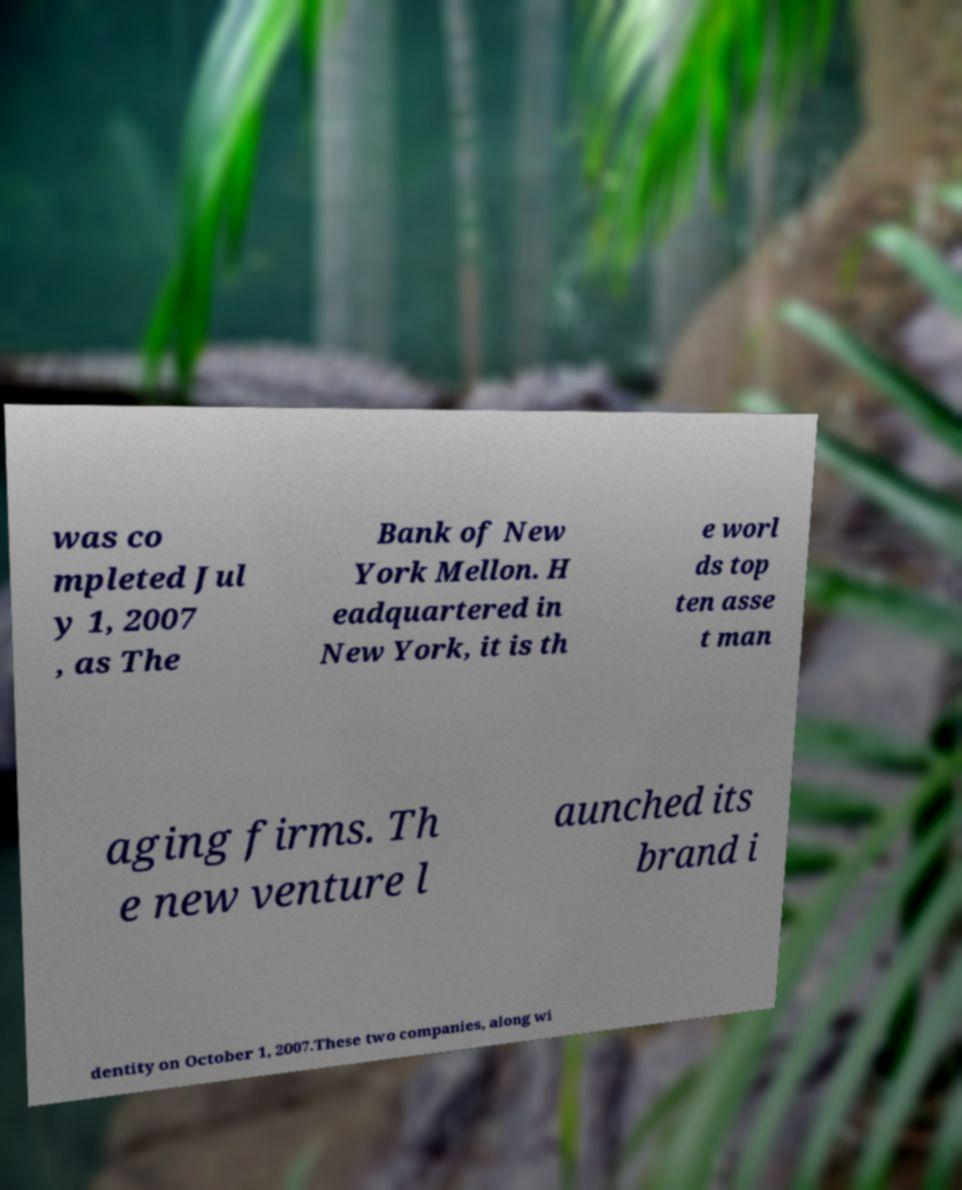Please identify and transcribe the text found in this image. was co mpleted Jul y 1, 2007 , as The Bank of New York Mellon. H eadquartered in New York, it is th e worl ds top ten asse t man aging firms. Th e new venture l aunched its brand i dentity on October 1, 2007.These two companies, along wi 